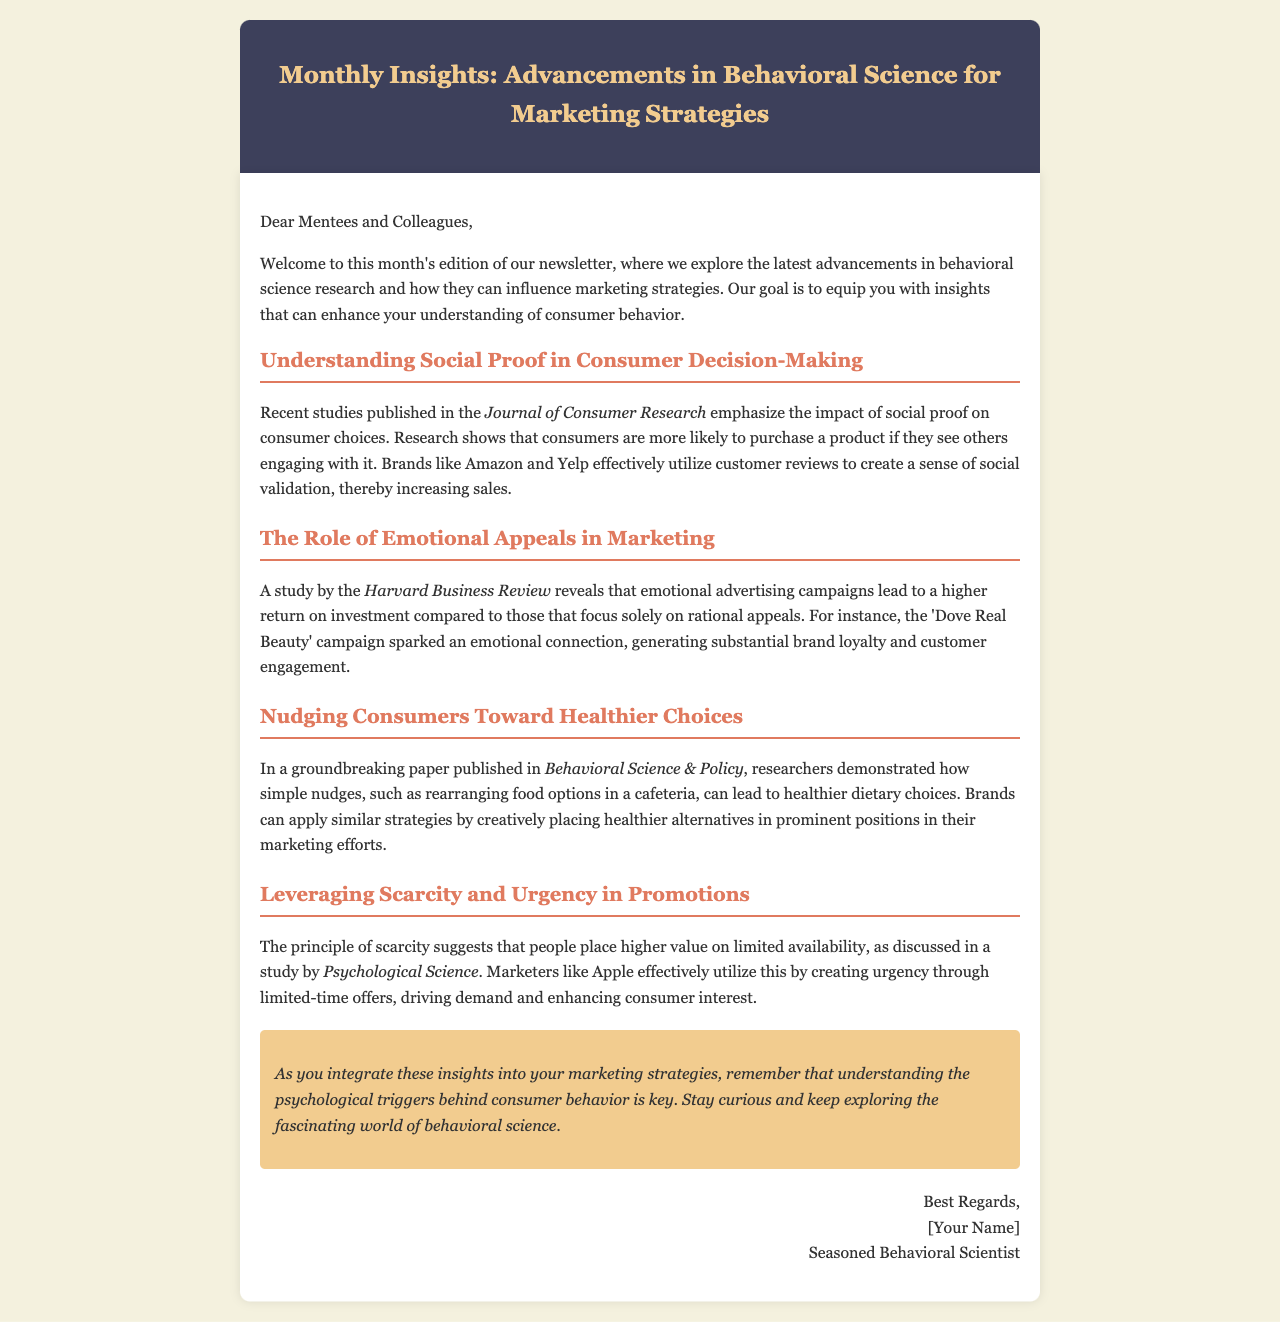What is the title of the newsletter? The title of the newsletter is stated in the header section of the document.
Answer: Monthly Insights: Advancements in Behavioral Science for Marketing Strategies Which journal highlights the impact of social proof? The document specifies a study published in a particular journal.
Answer: Journal of Consumer Research What campaign is mentioned as an example of emotional appeal? The document refers to a specific campaign illustrating emotional advertising effectiveness.
Answer: Dove Real Beauty Who published a paper on nudging consumers? The document attributes a groundbreaking paper to a specific organization.
Answer: Behavioral Science & Policy What principle is discussed regarding scarcity in promotions? The document describes a psychological principle that affects consumer behavior.
Answer: Scarcity What is one strategy brands can use from nudging research? The document provides a practical application derived from the research findings.
Answer: Rearranging food options How does emotional advertising affect ROI, according to the study? The document gives insight into the effectiveness of emotional advertising campaigns compared to rational ones.
Answer: Higher return on investment Which psychological trigger is emphasized in the conclusion? The conclusion of the document highlights the importance of understanding a specific factor in marketing.
Answer: Psychological triggers 